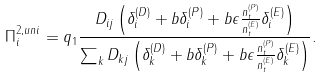Convert formula to latex. <formula><loc_0><loc_0><loc_500><loc_500>\Pi ^ { 2 , u n i } _ { i } = q _ { 1 } \frac { D _ { i j } \left ( \delta ^ { ( D ) } _ { i } + b \delta ^ { ( P ) } _ { i } + b \epsilon \frac { n _ { t } ^ { ( P ) } } { n _ { t } ^ { ( E ) } } \delta ^ { ( E ) } _ { i } \right ) } { \sum _ { k } D _ { k j } \left ( \delta ^ { ( D ) } _ { k } + b \delta ^ { ( P ) } _ { k } + b \epsilon \frac { n _ { t } ^ { ( P ) } } { n _ { t } ^ { ( E ) } } \delta ^ { ( E ) } _ { k } \right ) } .</formula> 